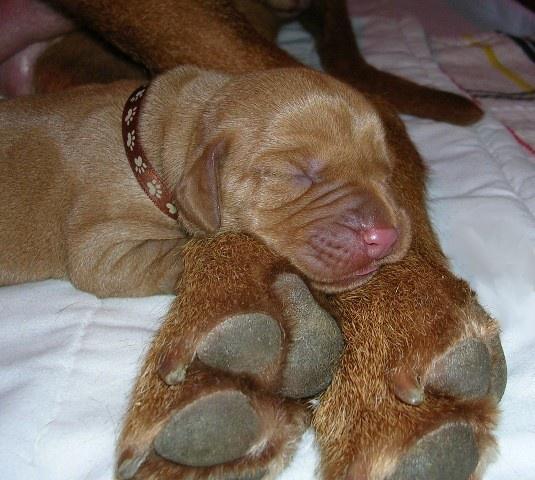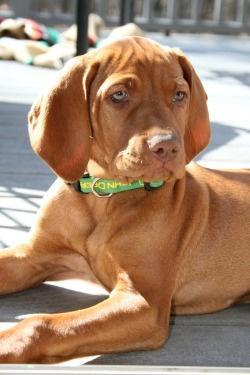The first image is the image on the left, the second image is the image on the right. For the images shown, is this caption "The left image includes at least one extended paw in the foreground, and a collar worn by a reclining dog." true? Answer yes or no. Yes. The first image is the image on the left, the second image is the image on the right. Considering the images on both sides, is "Two dogs are looking into the camera." valid? Answer yes or no. No. 